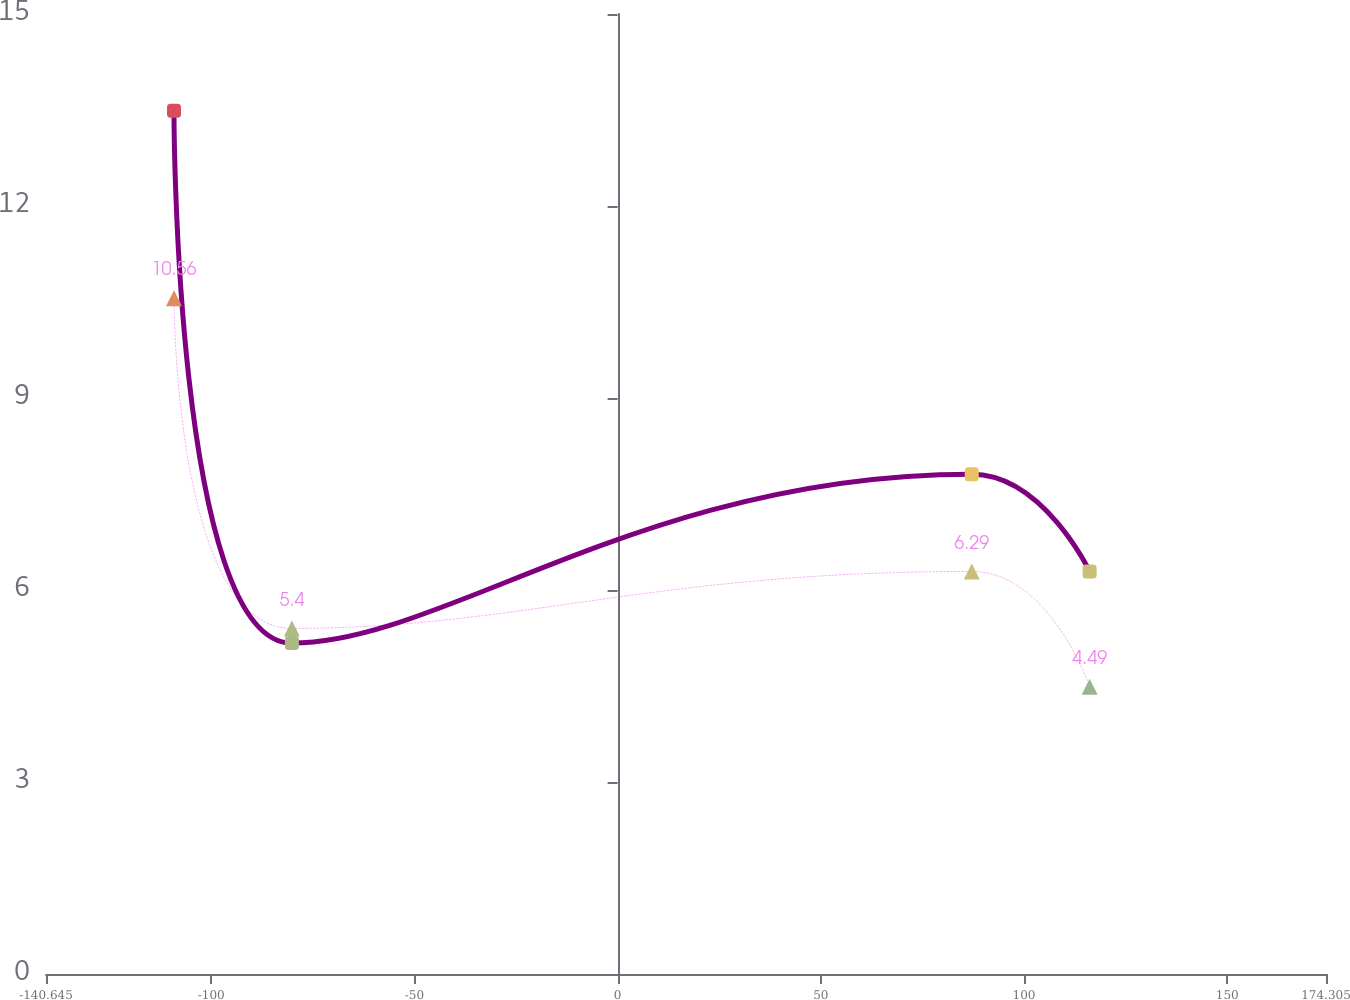<chart> <loc_0><loc_0><loc_500><loc_500><line_chart><ecel><fcel>2017<fcel>2016<nl><fcel>-109.15<fcel>10.56<fcel>13.49<nl><fcel>-80.14<fcel>5.4<fcel>5.17<nl><fcel>87.14<fcel>6.29<fcel>7.81<nl><fcel>116.15<fcel>4.49<fcel>6.29<nl><fcel>176.79<fcel>2.54<fcel>4.13<nl><fcel>205.8<fcel>1.65<fcel>3.09<nl></chart> 